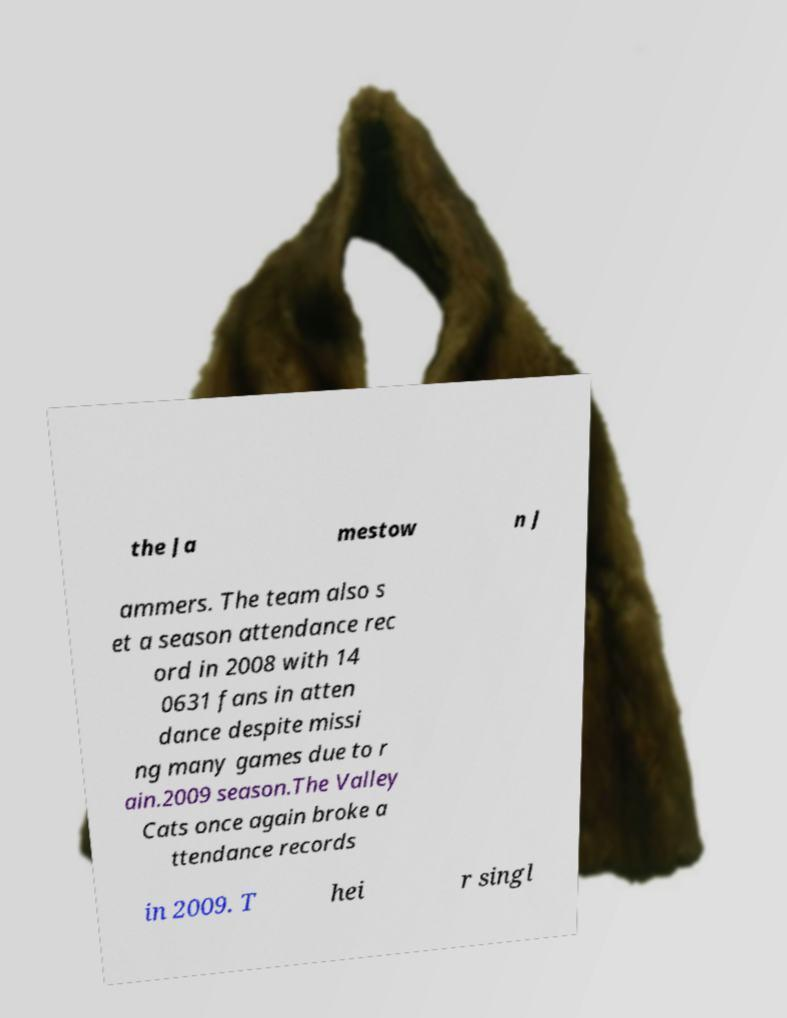Please read and relay the text visible in this image. What does it say? the Ja mestow n J ammers. The team also s et a season attendance rec ord in 2008 with 14 0631 fans in atten dance despite missi ng many games due to r ain.2009 season.The Valley Cats once again broke a ttendance records in 2009. T hei r singl 